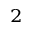<formula> <loc_0><loc_0><loc_500><loc_500>^ { 2 }</formula> 